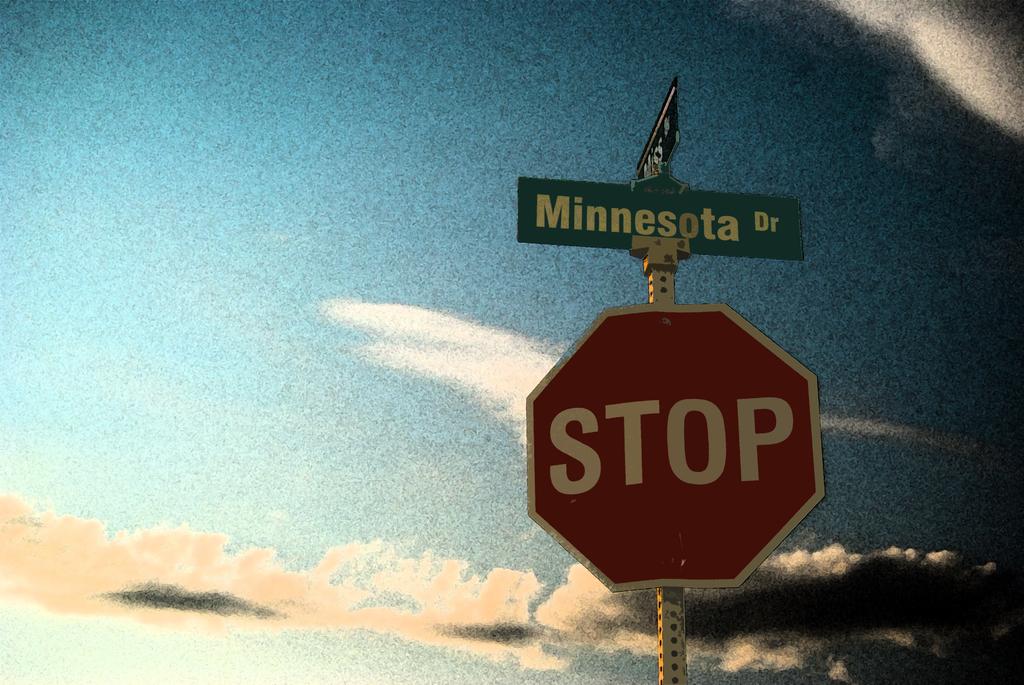What is the street name?
Keep it short and to the point. Minnesota dr. Is the street called minnesota street above the stop sign?
Your answer should be very brief. Yes. 